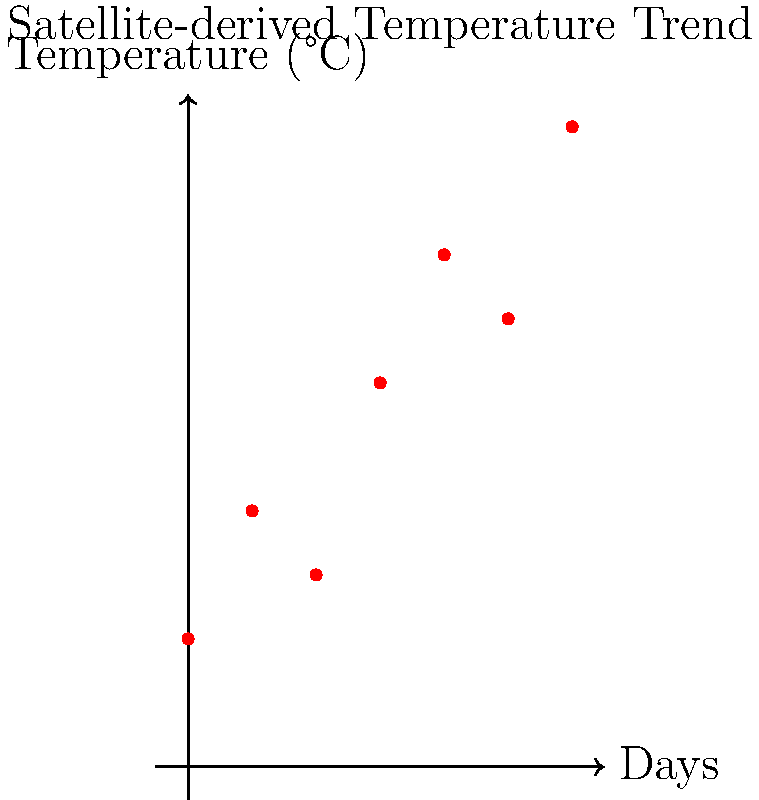Based on the satellite-derived temperature trend shown in the graph, what is the most likely temperature prediction for Day 7, assuming the trend continues? To predict the temperature for Day 7, we need to analyze the trend in the given data:

1. Observe the general trend: The temperature is increasing over time, with some fluctuations.

2. Calculate the overall change:
   Initial temperature (Day 0): 12°C
   Final temperature (Day 6): 20°C
   Total increase: 20°C - 12°C = 8°C
   
3. Calculate the average daily increase:
   Number of days: 6
   Average daily increase: 8°C ÷ 6 = 1.33°C per day

4. Consider recent trend: The last two days show an increase of 3°C (from 17°C to 20°C).

5. Estimate Day 7 temperature:
   - Using average increase: 20°C + 1.33°C ≈ 21.33°C
   - Considering recent trend: 20°C + 1.5°C = 21.5°C (half of the last 2-day increase)

6. Round to the nearest whole number, as weather forecasts typically use integer values.

Given the overall trend and recent data, a reasonable prediction for Day 7 would be 21°C or 22°C. We'll choose 21°C as it's closer to both estimates.
Answer: 21°C 